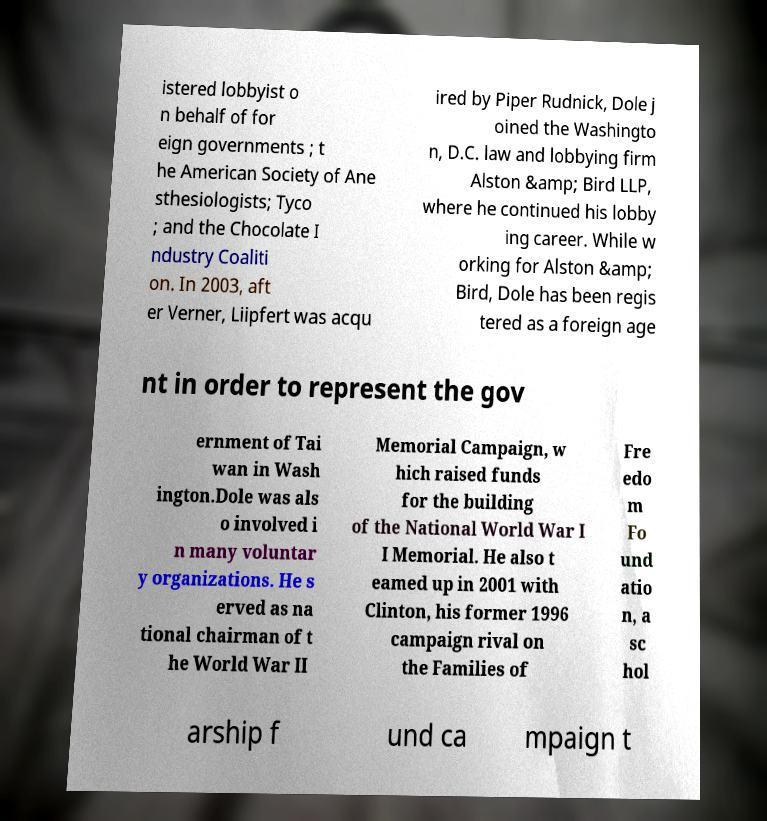I need the written content from this picture converted into text. Can you do that? istered lobbyist o n behalf of for eign governments ; t he American Society of Ane sthesiologists; Tyco ; and the Chocolate I ndustry Coaliti on. In 2003, aft er Verner, Liipfert was acqu ired by Piper Rudnick, Dole j oined the Washingto n, D.C. law and lobbying firm Alston &amp; Bird LLP, where he continued his lobby ing career. While w orking for Alston &amp; Bird, Dole has been regis tered as a foreign age nt in order to represent the gov ernment of Tai wan in Wash ington.Dole was als o involved i n many voluntar y organizations. He s erved as na tional chairman of t he World War II Memorial Campaign, w hich raised funds for the building of the National World War I I Memorial. He also t eamed up in 2001 with Clinton, his former 1996 campaign rival on the Families of Fre edo m Fo und atio n, a sc hol arship f und ca mpaign t 